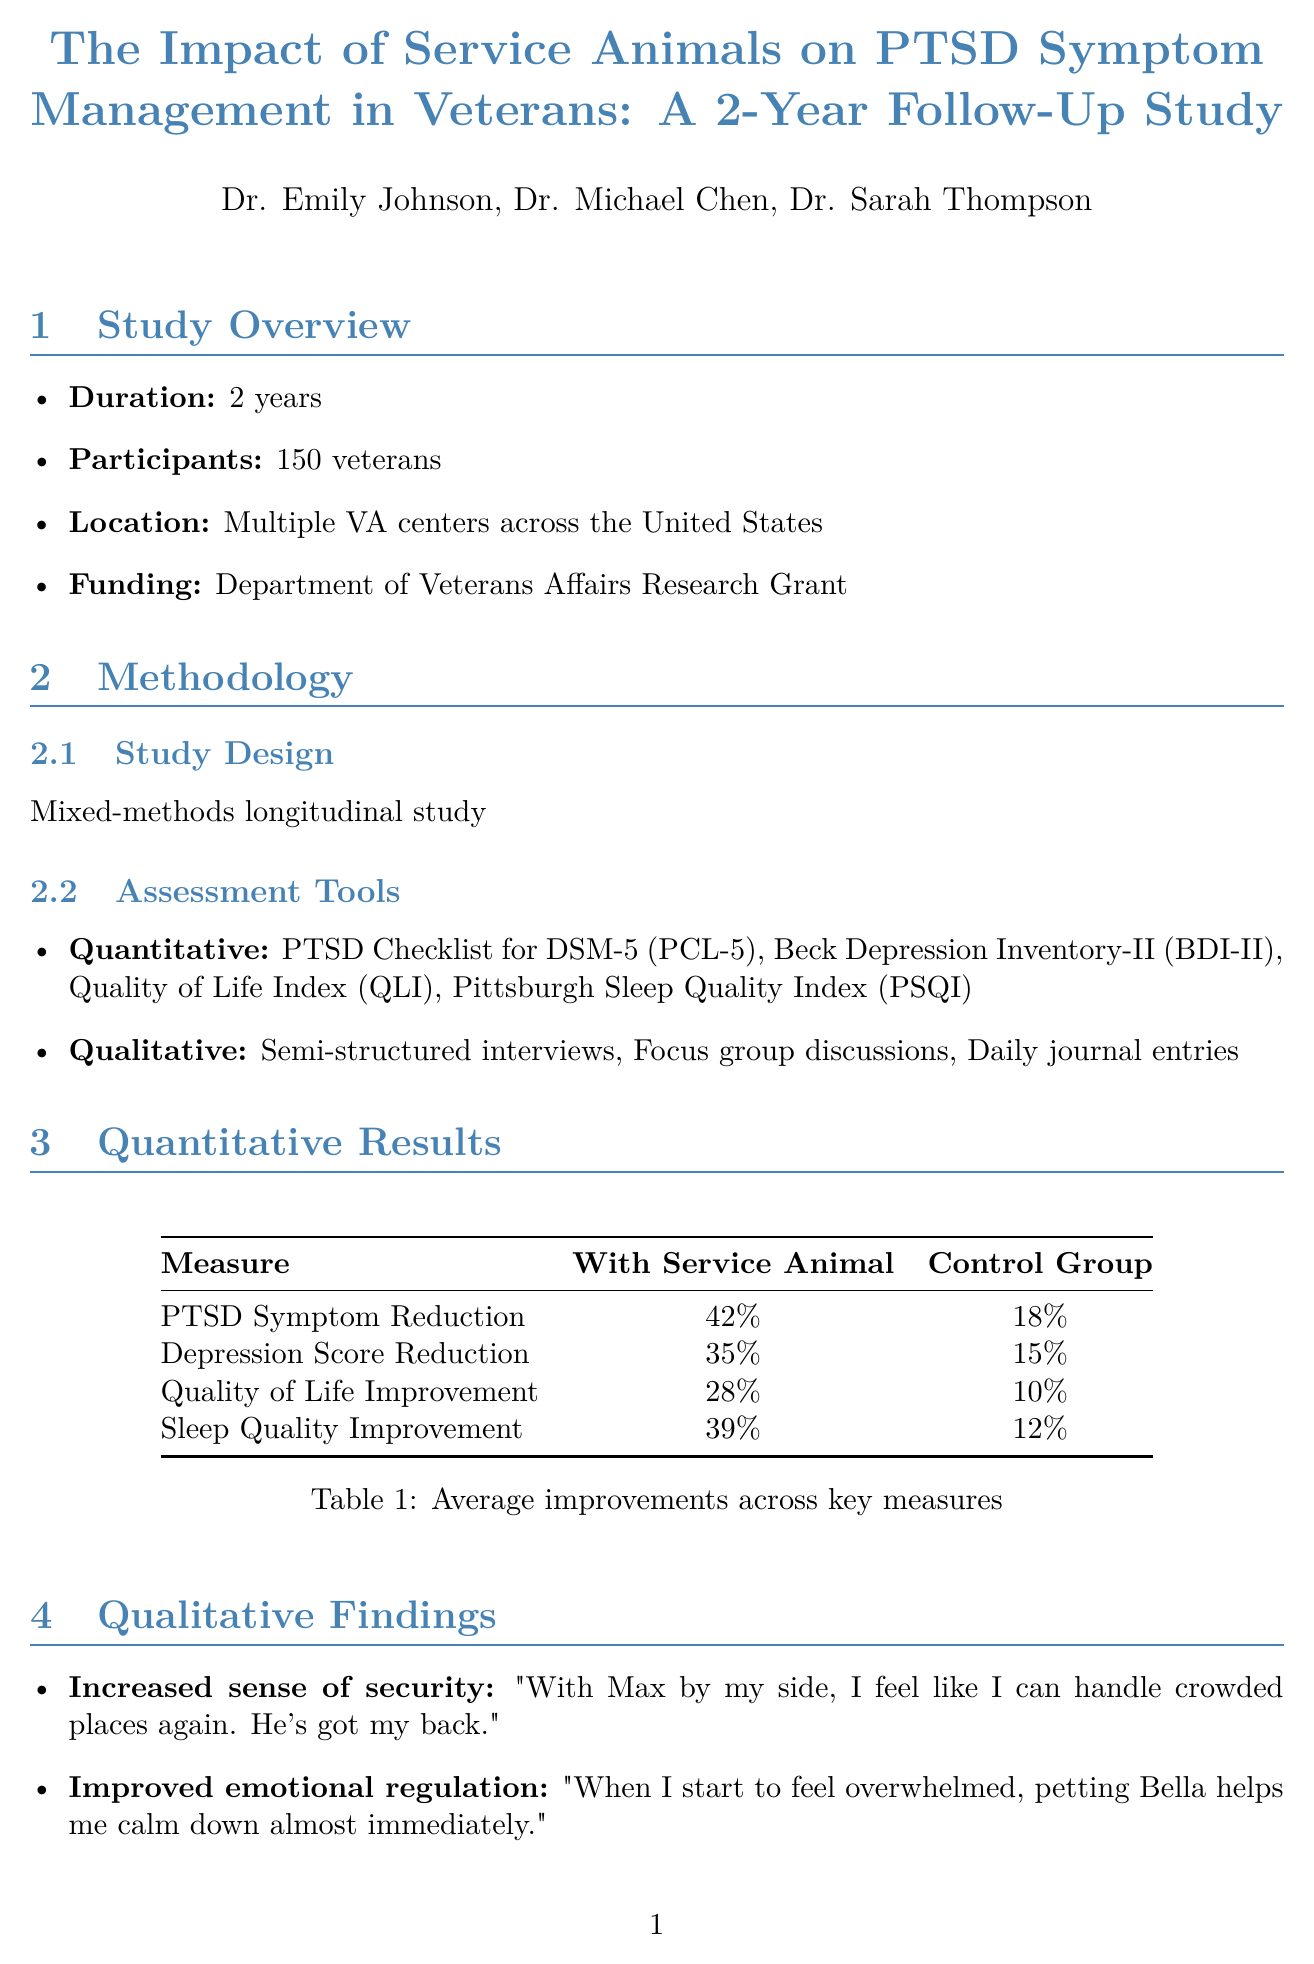what is the title of the study? The title of the study is provided in the document's title section, indicating the focus on service animals and PTSD.
Answer: The Impact of Service Animals on PTSD Symptom Management in Veterans: A 2-Year Follow-Up Study who are the researchers involved in this study? The names and affiliations of the researchers are listed in the document.
Answer: Dr. Emily Johnson, Dr. Michael Chen, Dr. Sarah Thompson how long did the study last? The duration of the study is clearly stated in the overview section of the document.
Answer: 2 years what percentage reduction in PTSD symptoms was reported by participants with a service animal? The findings highlight the average percentage reduction of PTSD symptoms in veterans with service animals compared to the control group.
Answer: 42% what qualitative theme relates to veterans feeling safer? The qualitative findings section includes various themes with descriptions and quotes from participants.
Answer: Increased sense of security what is the average improvement in sleep quality for veterans with service animals? The quantitative results provide specific percentages regarding various mental health measures, including sleep quality.
Answer: 39% what is one of the recommendations made in the study? The recommendations section lists suggestions based on the study's findings regarding service animals and veterans with PTSD.
Answer: Expand service animal programs within VA healthcare system what percentage increase in quality of life scores was observed for the control group? The quantitative results specify the improvements seen in both the service animal group and the control group.
Answer: 10% 